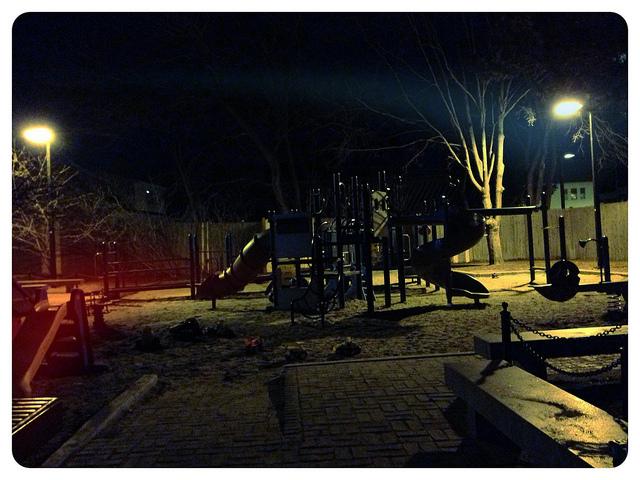What time of day is this?
Concise answer only. Night. How many trees are there?
Give a very brief answer. 2. How many people are in the scene?
Be succinct. 0. What are the benches made of?
Give a very brief answer. Wood. 